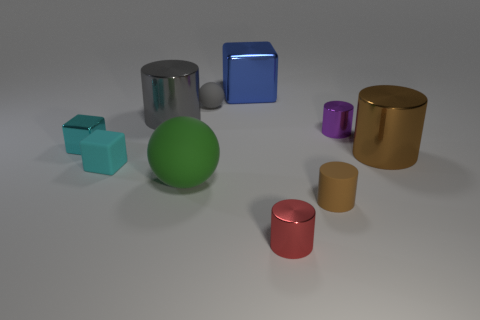Subtract all red cylinders. How many cylinders are left? 4 Subtract all cyan cylinders. Subtract all cyan spheres. How many cylinders are left? 5 Subtract all cubes. How many objects are left? 7 Add 2 small cylinders. How many small cylinders exist? 5 Subtract 0 cyan cylinders. How many objects are left? 10 Subtract all large blue rubber spheres. Subtract all rubber blocks. How many objects are left? 9 Add 7 tiny gray things. How many tiny gray things are left? 8 